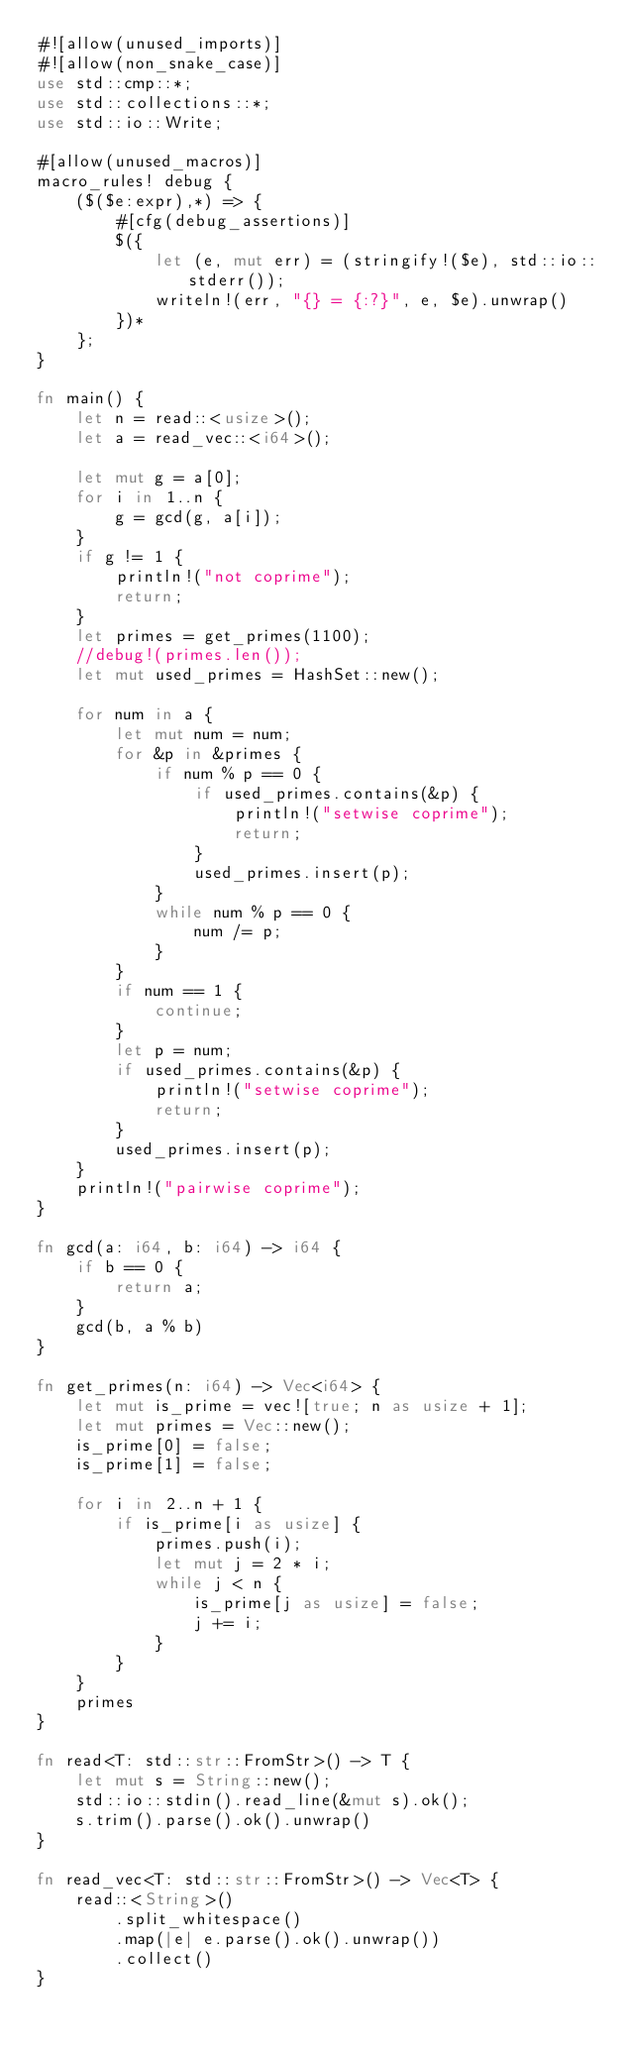<code> <loc_0><loc_0><loc_500><loc_500><_Rust_>#![allow(unused_imports)]
#![allow(non_snake_case)]
use std::cmp::*;
use std::collections::*;
use std::io::Write;

#[allow(unused_macros)]
macro_rules! debug {
    ($($e:expr),*) => {
        #[cfg(debug_assertions)]
        $({
            let (e, mut err) = (stringify!($e), std::io::stderr());
            writeln!(err, "{} = {:?}", e, $e).unwrap()
        })*
    };
}

fn main() {
    let n = read::<usize>();
    let a = read_vec::<i64>();

    let mut g = a[0];
    for i in 1..n {
        g = gcd(g, a[i]);
    }
    if g != 1 {
        println!("not coprime");
        return;
    }
    let primes = get_primes(1100);
    //debug!(primes.len());
    let mut used_primes = HashSet::new();

    for num in a {
        let mut num = num;
        for &p in &primes {
            if num % p == 0 {
                if used_primes.contains(&p) {
                    println!("setwise coprime");
                    return;
                }
                used_primes.insert(p);
            }
            while num % p == 0 {
                num /= p;
            }
        }
        if num == 1 {
            continue;
        }
        let p = num;
        if used_primes.contains(&p) {
            println!("setwise coprime");
            return;
        }
        used_primes.insert(p);
    }
    println!("pairwise coprime");
}

fn gcd(a: i64, b: i64) -> i64 {
    if b == 0 {
        return a;
    }
    gcd(b, a % b)
}

fn get_primes(n: i64) -> Vec<i64> {
    let mut is_prime = vec![true; n as usize + 1];
    let mut primes = Vec::new();
    is_prime[0] = false;
    is_prime[1] = false;

    for i in 2..n + 1 {
        if is_prime[i as usize] {
            primes.push(i);
            let mut j = 2 * i;
            while j < n {
                is_prime[j as usize] = false;
                j += i;
            }
        }
    }
    primes
}

fn read<T: std::str::FromStr>() -> T {
    let mut s = String::new();
    std::io::stdin().read_line(&mut s).ok();
    s.trim().parse().ok().unwrap()
}

fn read_vec<T: std::str::FromStr>() -> Vec<T> {
    read::<String>()
        .split_whitespace()
        .map(|e| e.parse().ok().unwrap())
        .collect()
}
</code> 